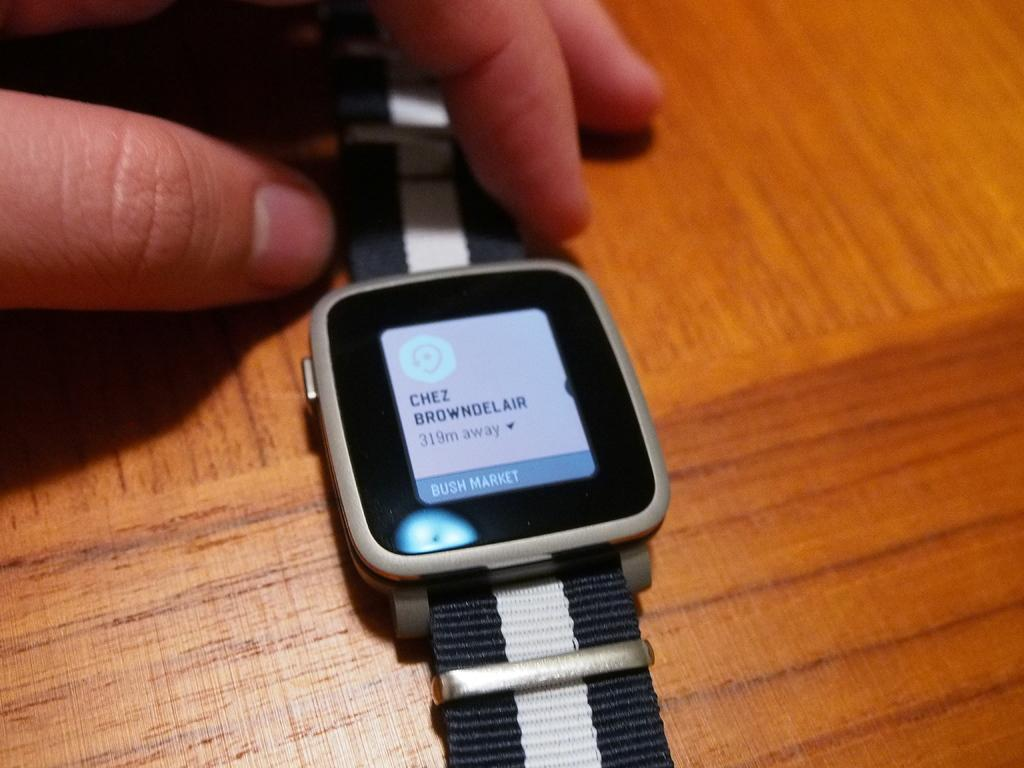Provide a one-sentence caption for the provided image. A watch with the name Chez Browndelair on the home screen. 